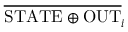<formula> <loc_0><loc_0><loc_500><loc_500>\overline { S T A T E \oplus O U T } _ { i }</formula> 